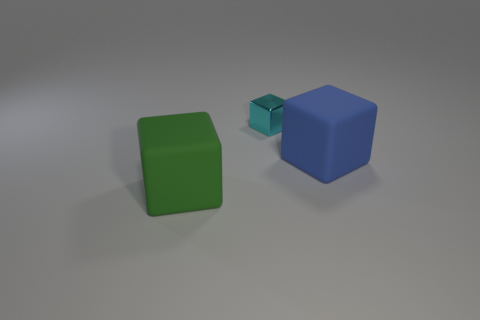Is there anything else that has the same size as the metallic thing?
Your response must be concise. No. Does the metallic thing have the same size as the green rubber block?
Keep it short and to the point. No. What size is the thing in front of the big rubber object that is right of the tiny object?
Keep it short and to the point. Large. There is a object that is behind the green rubber block and left of the big blue thing; how big is it?
Make the answer very short. Small. How many yellow matte objects have the same size as the green matte cube?
Ensure brevity in your answer.  0. What number of rubber things are large blue blocks or big red spheres?
Your answer should be very brief. 1. What is the material of the large block that is on the right side of the big rubber object that is left of the small cyan block?
Offer a terse response. Rubber. How many objects are either small cyan things or things that are in front of the cyan block?
Give a very brief answer. 3. What is the size of the blue object that is made of the same material as the green cube?
Give a very brief answer. Large. How many cyan objects are either metal cubes or blocks?
Keep it short and to the point. 1. 